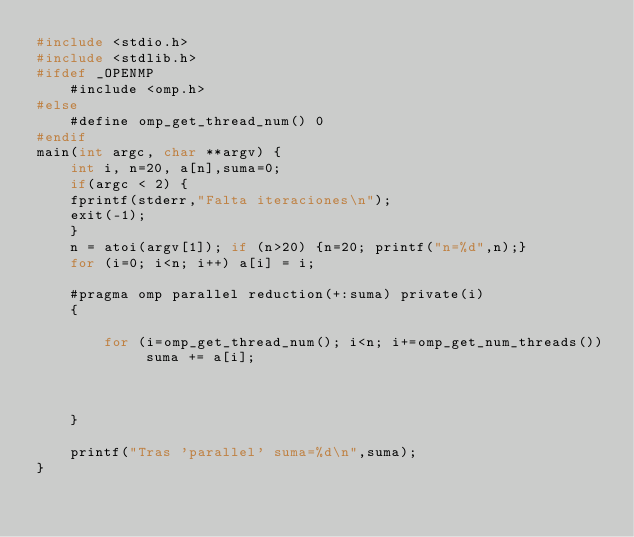Convert code to text. <code><loc_0><loc_0><loc_500><loc_500><_C_>#include <stdio.h>
#include <stdlib.h>
#ifdef _OPENMP
	#include <omp.h>
#else
	#define omp_get_thread_num() 0
#endif
main(int argc, char **argv) {
	int i, n=20, a[n],suma=0;
	if(argc < 2) {
	fprintf(stderr,"Falta iteraciones\n");
	exit(-1);
	}
	n = atoi(argv[1]); if (n>20) {n=20; printf("n=%d",n);}
	for (i=0; i<n; i++) a[i] = i;

	#pragma omp parallel reduction(+:suma) private(i)
	{
		
		for (i=omp_get_thread_num(); i<n; i+=omp_get_num_threads()) suma += a[i];
		

		
	}

	printf("Tras 'parallel' suma=%d\n",suma);
}
</code> 